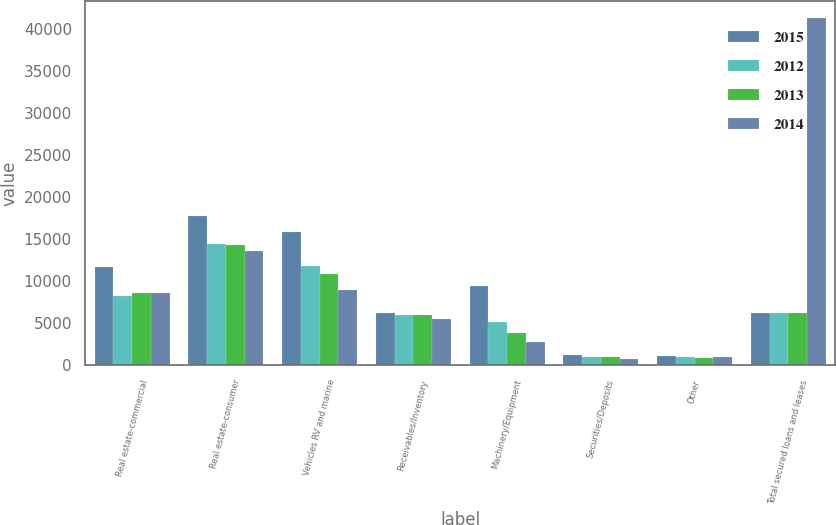Convert chart to OTSL. <chart><loc_0><loc_0><loc_500><loc_500><stacked_bar_chart><ecel><fcel>Real estate-commercial<fcel>Real estate-consumer<fcel>Vehicles RV and marine<fcel>Receivables/Inventory<fcel>Machinery/Equipment<fcel>Securities/Deposits<fcel>Other<fcel>Total secured loans and leases<nl><fcel>2015<fcel>11729<fcel>17831<fcel>15934<fcel>6277<fcel>9465<fcel>1305<fcel>1154<fcel>6277<nl><fcel>2012<fcel>8296<fcel>14469<fcel>11880<fcel>5961<fcel>5171<fcel>974<fcel>987<fcel>6277<nl><fcel>2013<fcel>8631<fcel>14322<fcel>10932<fcel>5968<fcel>3863<fcel>964<fcel>919<fcel>6277<nl><fcel>2014<fcel>8622<fcel>13657<fcel>8989<fcel>5534<fcel>2738<fcel>786<fcel>1016<fcel>41342<nl></chart> 